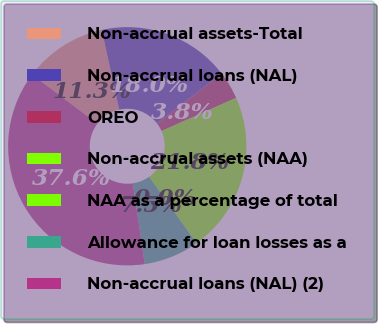<chart> <loc_0><loc_0><loc_500><loc_500><pie_chart><fcel>Non-accrual assets-Total<fcel>Non-accrual loans (NAL)<fcel>OREO<fcel>Non-accrual assets (NAA)<fcel>NAA as a percentage of total<fcel>Allowance for loan losses as a<fcel>Non-accrual loans (NAL) (2)<nl><fcel>11.29%<fcel>18.02%<fcel>3.76%<fcel>21.78%<fcel>0.0%<fcel>7.53%<fcel>37.62%<nl></chart> 